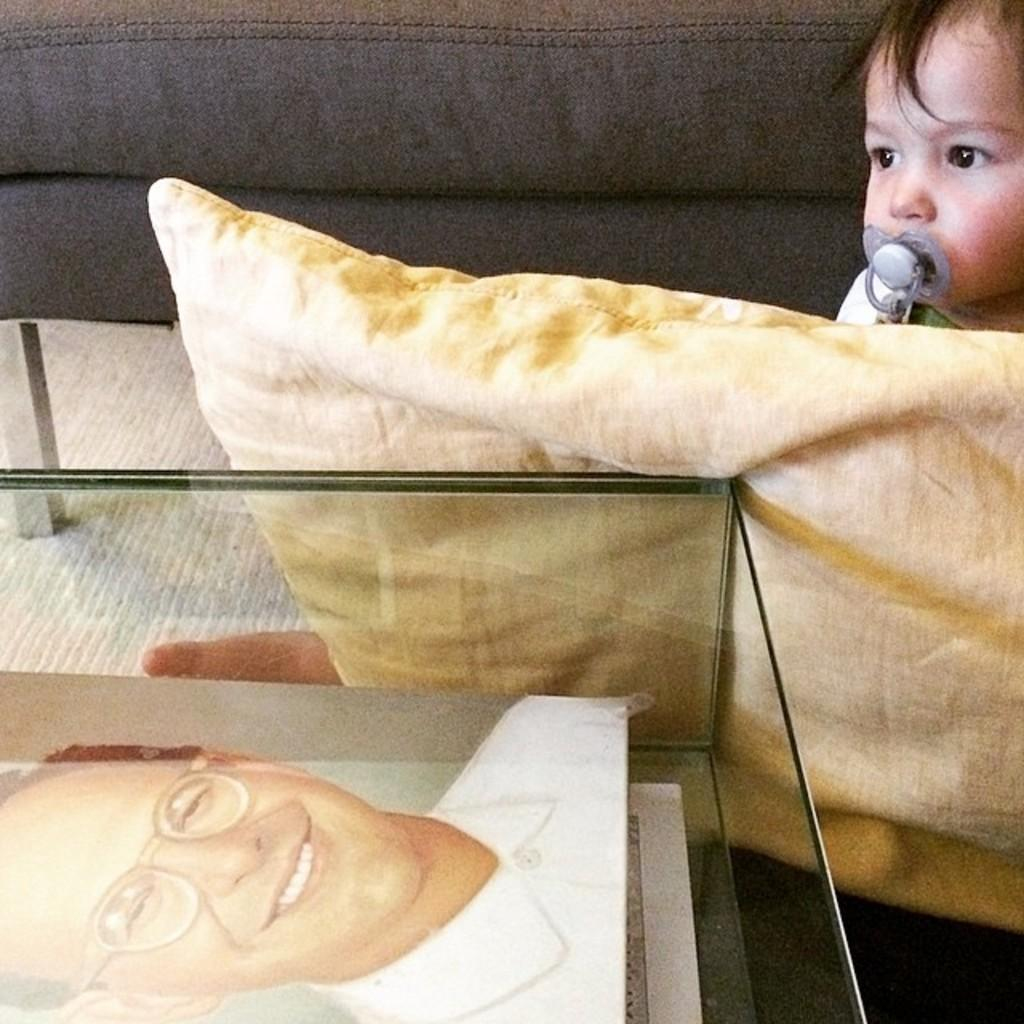What is the boy doing in the image? The boy is sitting on a couch. What is in front of the couch? There is a glass table in front of the couch. Is there anything between the couch and the table? Yes, there is a pillow between the couch and the table. What type of vegetable is on the page next to the boy? There is no vegetable or page present in the image; it only features a boy sitting on a couch with a glass table and a pillow in front of him. 